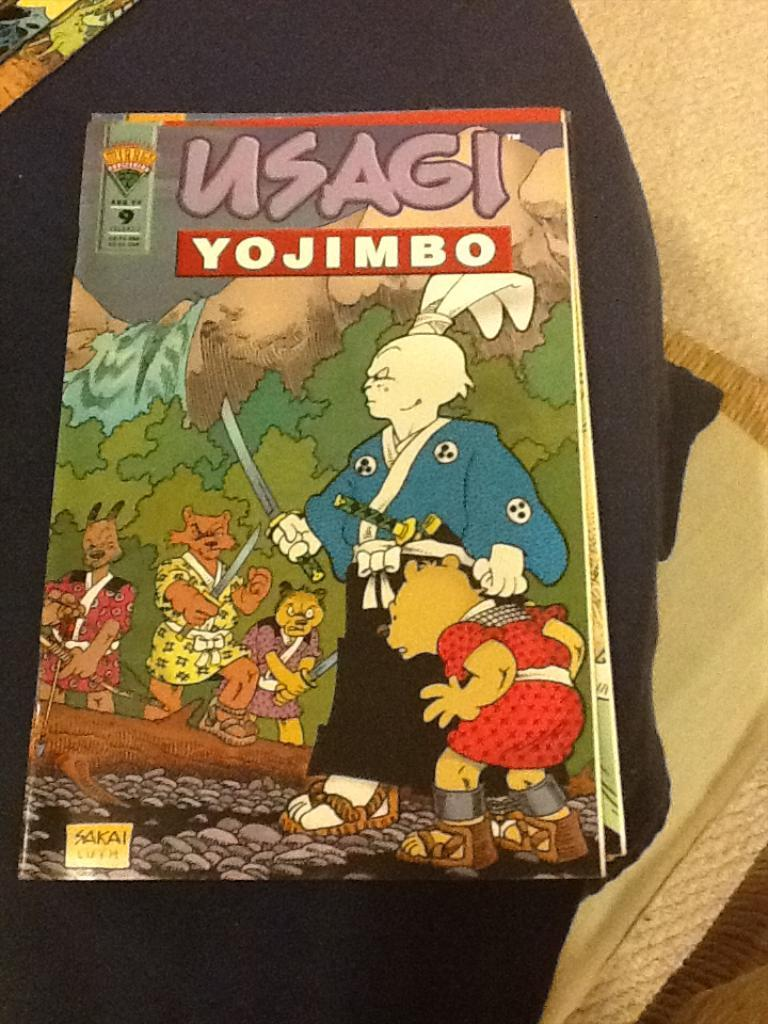Provide a one-sentence caption for the provided image. An anime comic book that is called Usagi Yojimbo. 